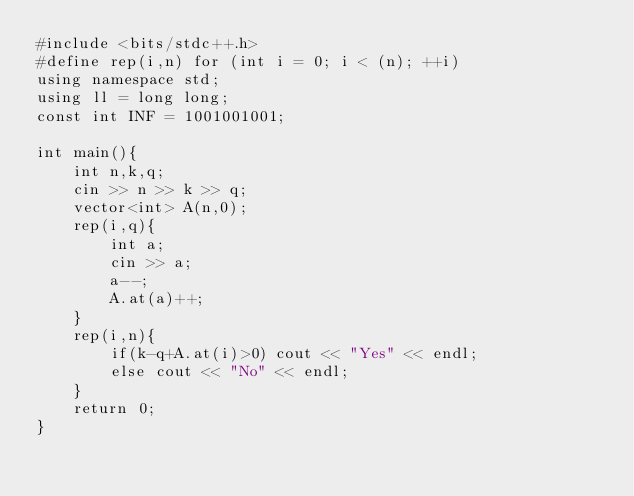Convert code to text. <code><loc_0><loc_0><loc_500><loc_500><_C++_>#include <bits/stdc++.h>
#define rep(i,n) for (int i = 0; i < (n); ++i)
using namespace std;
using ll = long long;
const int INF = 1001001001;

int main(){
    int n,k,q;
    cin >> n >> k >> q;
    vector<int> A(n,0);
    rep(i,q){
        int a;
        cin >> a;
        a--;
        A.at(a)++;
    }
    rep(i,n){
        if(k-q+A.at(i)>0) cout << "Yes" << endl;
        else cout << "No" << endl;
    }
    return 0;
}</code> 